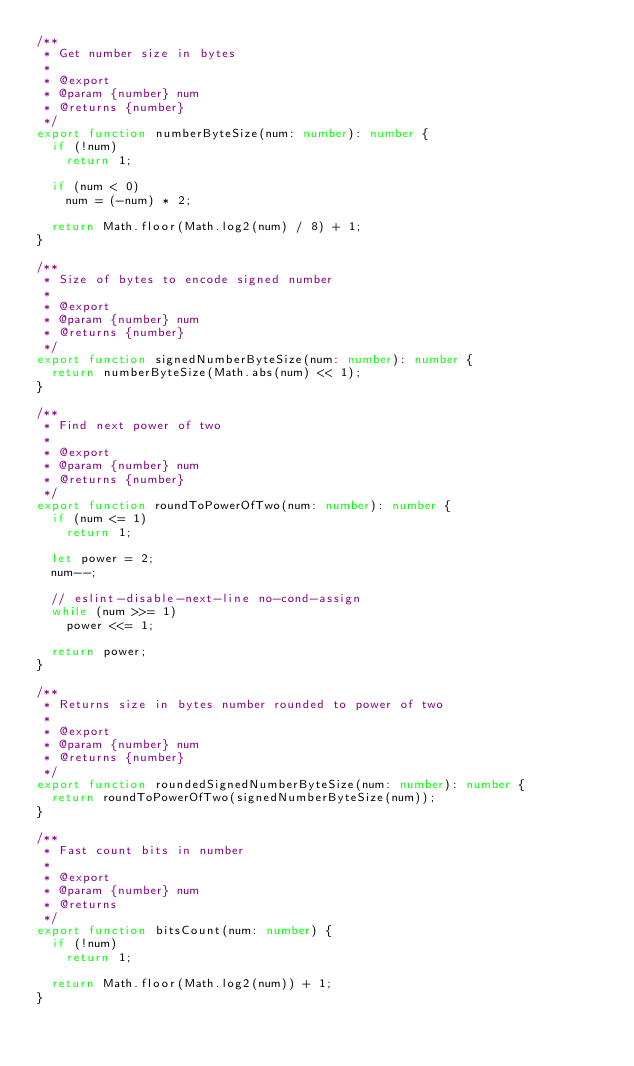Convert code to text. <code><loc_0><loc_0><loc_500><loc_500><_TypeScript_>/**
 * Get number size in bytes
 *
 * @export
 * @param {number} num
 * @returns {number}
 */
export function numberByteSize(num: number): number {
  if (!num)
    return 1;

  if (num < 0)
    num = (-num) * 2;

  return Math.floor(Math.log2(num) / 8) + 1;
}

/**
 * Size of bytes to encode signed number
 *
 * @export
 * @param {number} num
 * @returns {number}
 */
export function signedNumberByteSize(num: number): number {
  return numberByteSize(Math.abs(num) << 1);
}

/**
 * Find next power of two
 *
 * @export
 * @param {number} num
 * @returns {number}
 */
export function roundToPowerOfTwo(num: number): number {
  if (num <= 1)
    return 1;

  let power = 2;
  num--;

  // eslint-disable-next-line no-cond-assign
  while (num >>= 1)
    power <<= 1;

  return power;
}

/**
 * Returns size in bytes number rounded to power of two
 *
 * @export
 * @param {number} num
 * @returns {number}
 */
export function roundedSignedNumberByteSize(num: number): number {
  return roundToPowerOfTwo(signedNumberByteSize(num));
}

/**
 * Fast count bits in number
 *
 * @export
 * @param {number} num
 * @returns
 */
export function bitsCount(num: number) {
  if (!num)
    return 1;

  return Math.floor(Math.log2(num)) + 1;
}
</code> 